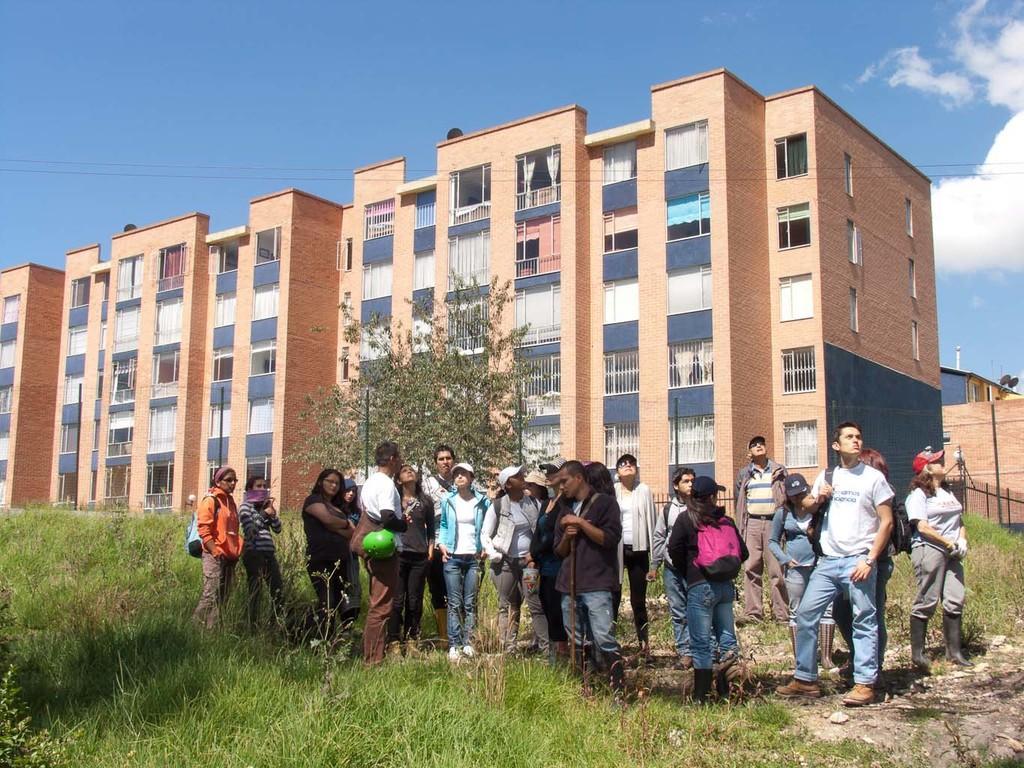Can you describe this image briefly? In this image there are people standing on the grass. In the background there is a building and also tree. At the top there is sky with some clouds. 